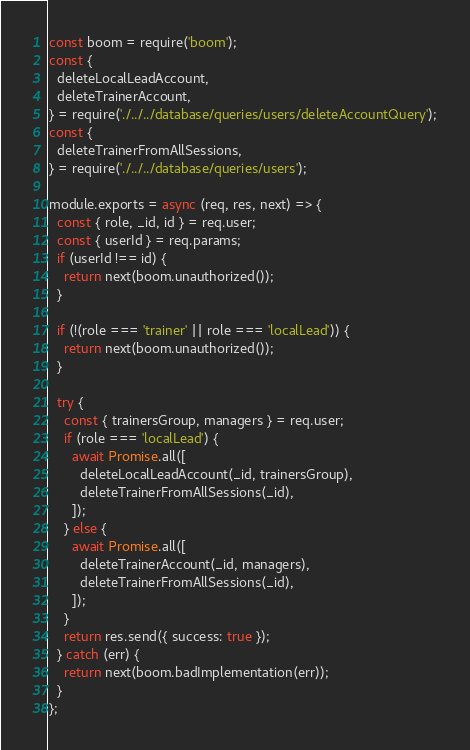<code> <loc_0><loc_0><loc_500><loc_500><_JavaScript_>const boom = require('boom');
const {
  deleteLocalLeadAccount,
  deleteTrainerAccount,
} = require('./../../database/queries/users/deleteAccountQuery');
const {
  deleteTrainerFromAllSessions,
} = require('./../../database/queries/users');

module.exports = async (req, res, next) => {
  const { role, _id, id } = req.user;
  const { userId } = req.params;
  if (userId !== id) {
    return next(boom.unauthorized());
  }

  if (!(role === 'trainer' || role === 'localLead')) {
    return next(boom.unauthorized());
  }

  try {
    const { trainersGroup, managers } = req.user;
    if (role === 'localLead') {
      await Promise.all([
        deleteLocalLeadAccount(_id, trainersGroup),
        deleteTrainerFromAllSessions(_id),
      ]);
    } else {
      await Promise.all([
        deleteTrainerAccount(_id, managers),
        deleteTrainerFromAllSessions(_id),
      ]);
    }
    return res.send({ success: true });
  } catch (err) {
    return next(boom.badImplementation(err));
  }
};
</code> 